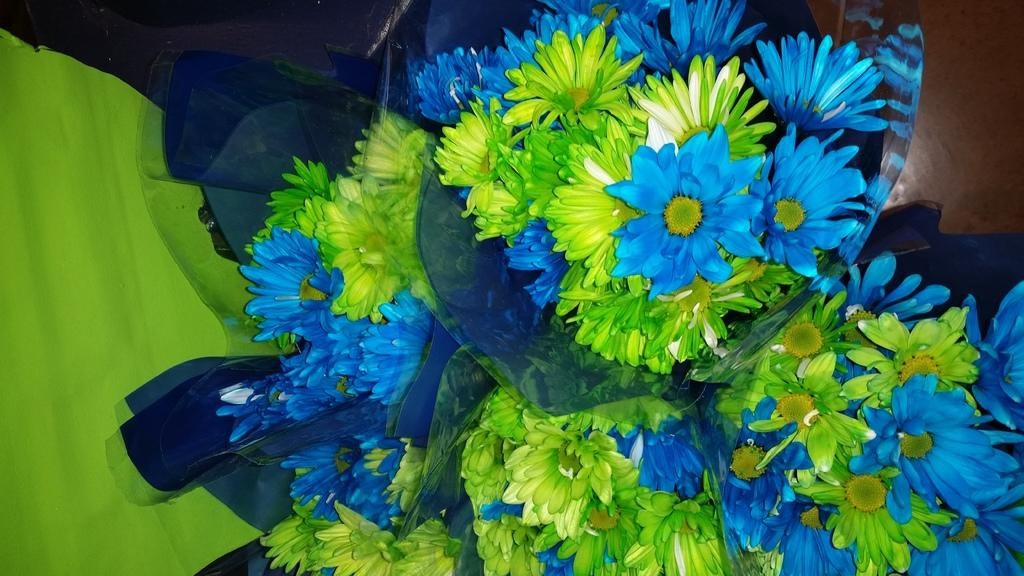What is the main subject in the center of the image? There are flower bouquets in the center of the image. What else can be seen on the right side of the image? There is a paper on the right side of the image. Where is the heart located in the image? There is no heart present in the image. What type of town is depicted in the image? The image does not depict a town; it only shows flower bouquets and a paper. 